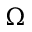Convert formula to latex. <formula><loc_0><loc_0><loc_500><loc_500>\Omega</formula> 